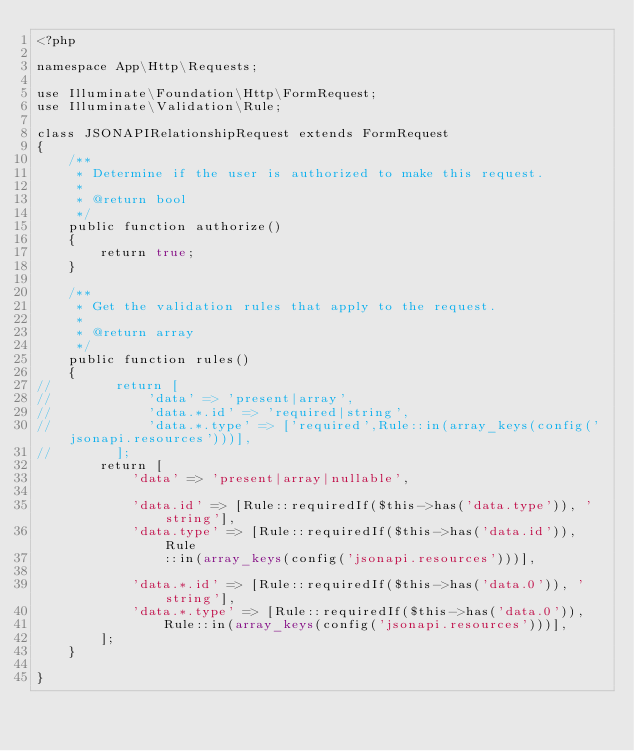Convert code to text. <code><loc_0><loc_0><loc_500><loc_500><_PHP_><?php

namespace App\Http\Requests;

use Illuminate\Foundation\Http\FormRequest;
use Illuminate\Validation\Rule;

class JSONAPIRelationshipRequest extends FormRequest
{
    /**
     * Determine if the user is authorized to make this request.
     *
     * @return bool
     */
    public function authorize()
    {
        return true;
    }

    /**
     * Get the validation rules that apply to the request.
     *
     * @return array
     */
    public function rules()
    {
//        return [
//            'data' => 'present|array',
//            'data.*.id' => 'required|string',
//            'data.*.type' => ['required',Rule::in(array_keys(config('jsonapi.resources')))],
//        ];
        return [
            'data' => 'present|array|nullable',

            'data.id' => [Rule::requiredIf($this->has('data.type')), 'string'],
            'data.type' => [Rule::requiredIf($this->has('data.id')), Rule
                ::in(array_keys(config('jsonapi.resources')))],

            'data.*.id' => [Rule::requiredIf($this->has('data.0')), 'string'],
            'data.*.type' => [Rule::requiredIf($this->has('data.0')),
                Rule::in(array_keys(config('jsonapi.resources')))],
        ];
    }

}
</code> 